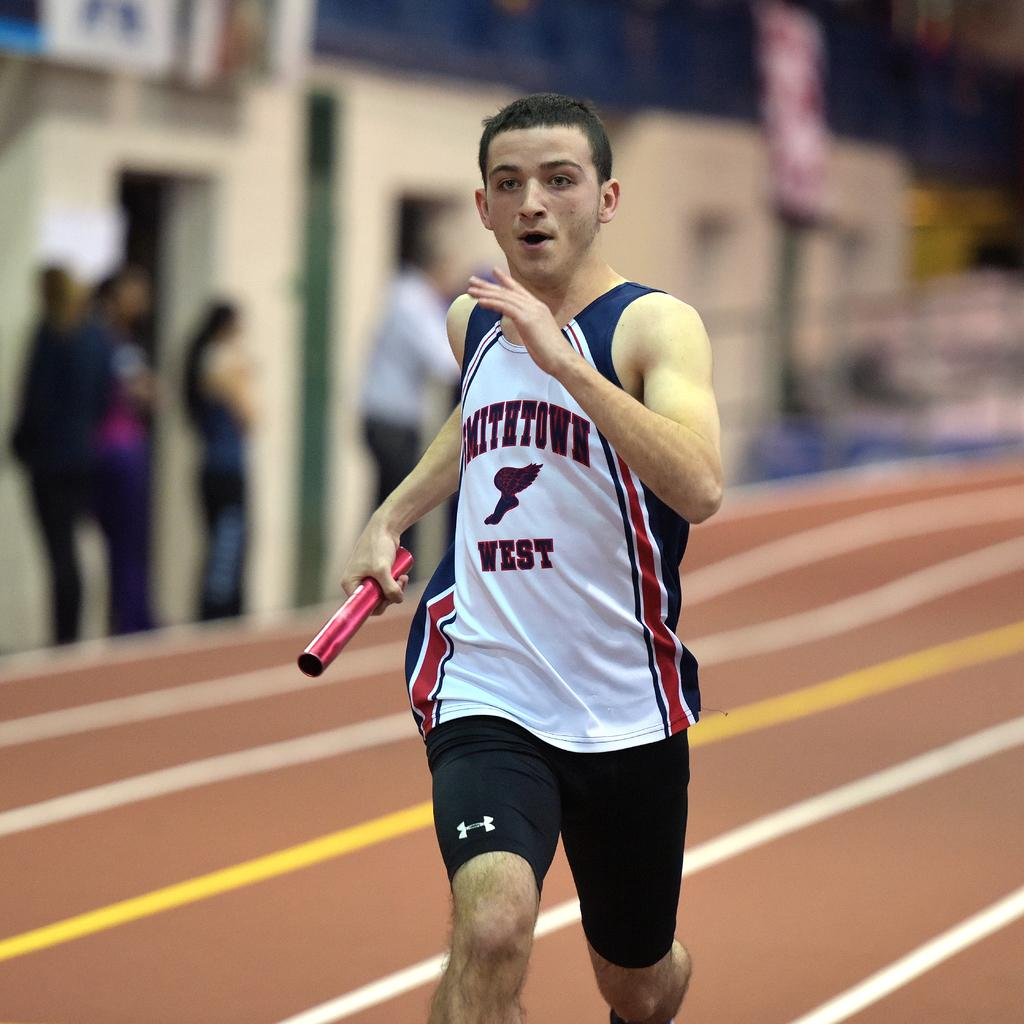What is the main subject of the image? The main subject of the image is a man. What is the man holding in his hand? The man is holding a rod in his hand. What is the man doing in the image? The man is running on the ground. What can be seen in the background of the image? There are people standing and a building in the background of the image. How would you describe the background of the image? The background of the image is blurry. What type of bell can be heard ringing in the image? There is no bell present in the image, and therefore no sound can be heard. 